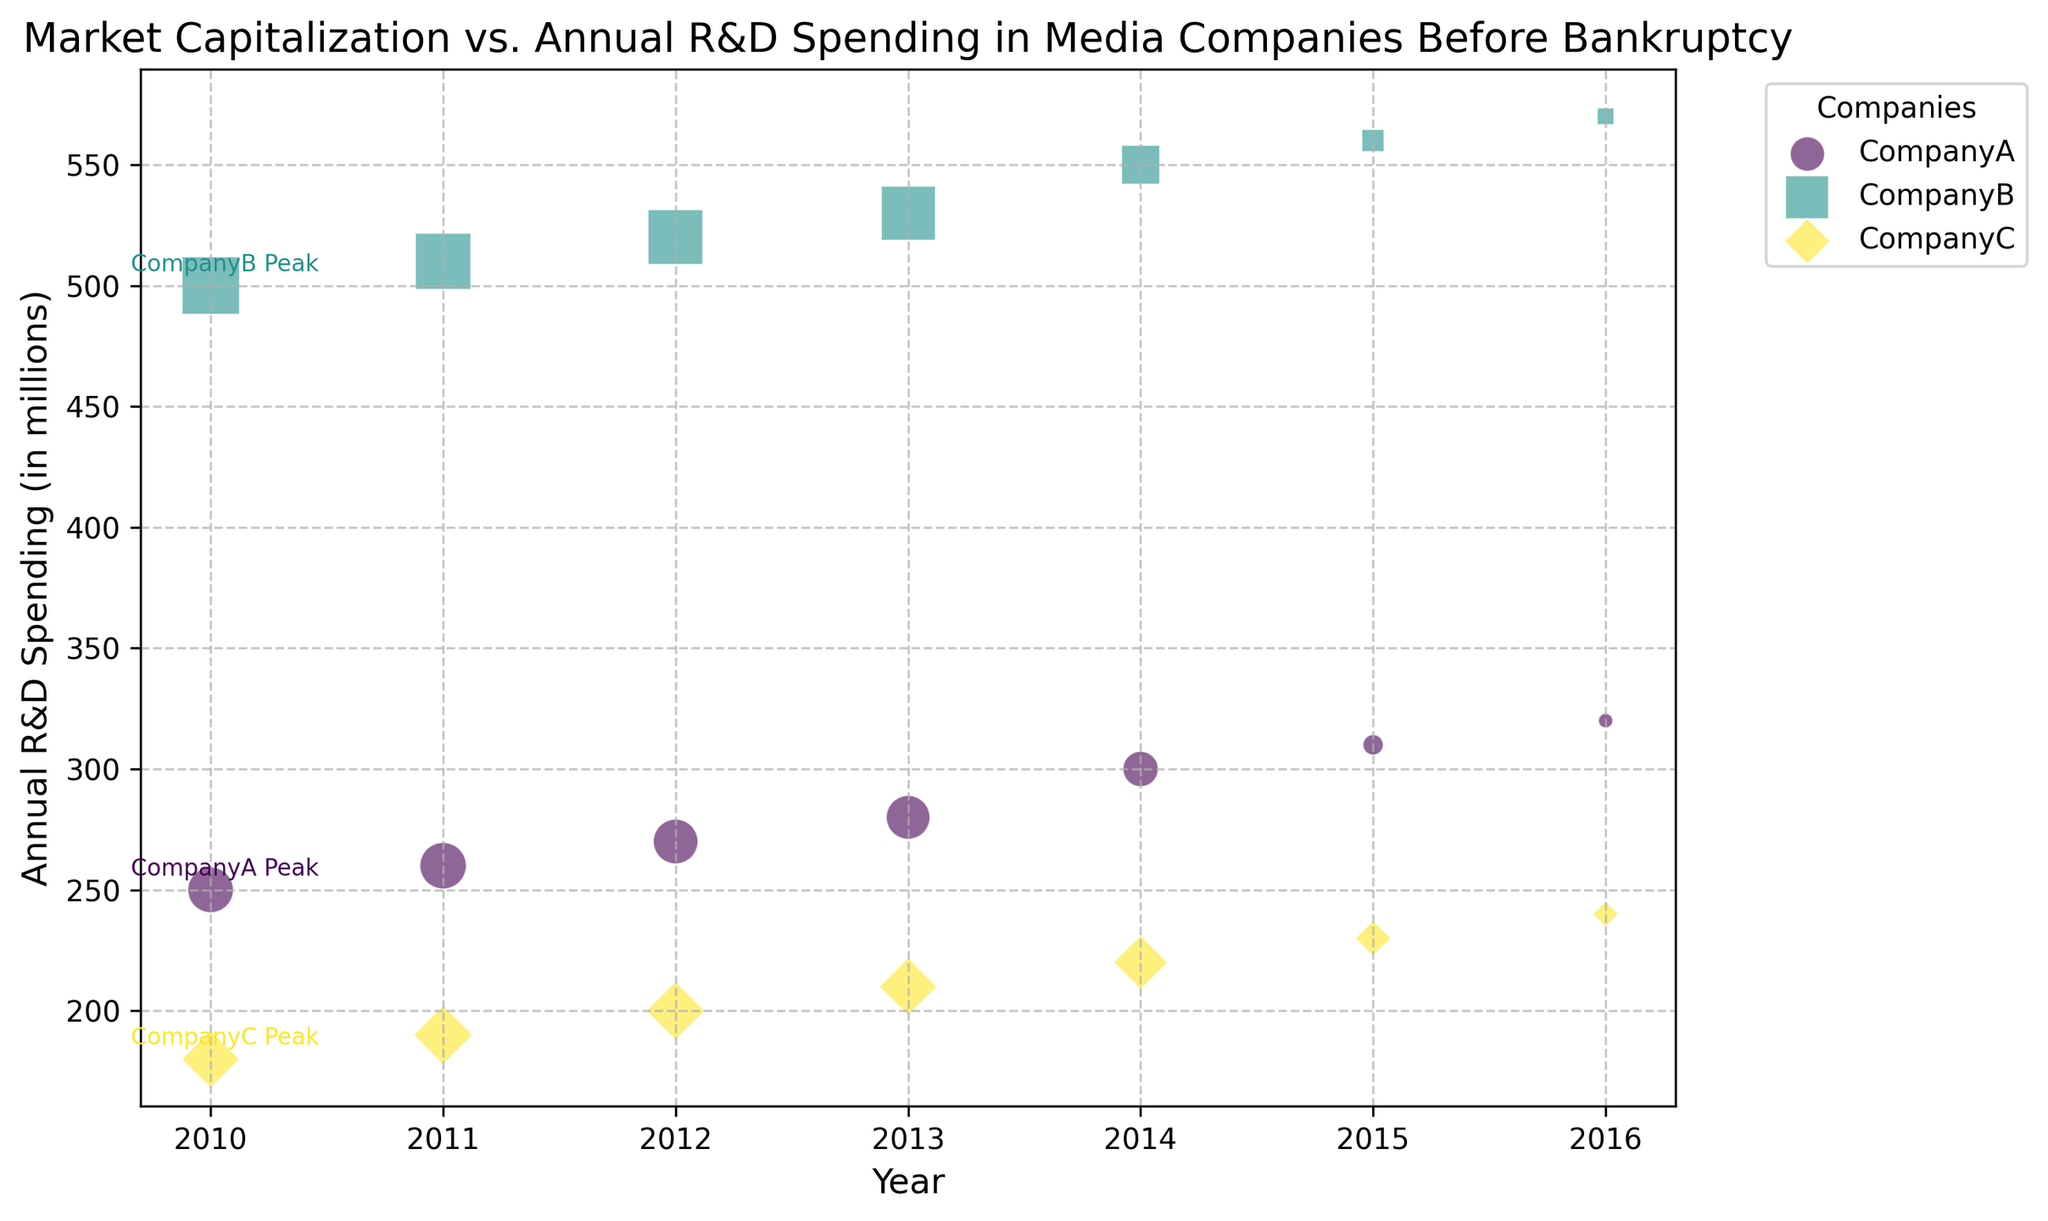what year did Company B have its peak R&D spending annotated, and what was the value? Locate the annotation for Company B peak year performance, which is identified visually near the data points for Company B. The annotation suggests the year and the corresponding R&D spending value.
Answer: 2010, 500 Which company had the highest R&D spending in their peak year? Check the annotated peak year performance for each company and compare the R&D spending values. The company with the highest value is the answer.
Answer: Company B During which years did Company A's Market Capitalization see the largest drop, based on the shift in marker size? Look for the biggest visible decrease in marker size for Company A, indicating a significant drop in market capitalization. This drop is most pronounced between the years 2014 and 2015.
Answer: Between 2014 and 2015 How does Company C's R&D spending trend over the years compare to its Market Capitalization trend? Identify the trend of annual R&D spending and compare it visually to the marker sizes representing market capitalization for Company C over the years. You will observe that R&D spending increases while market capitalization decreases.
Answer: Inverse trends What is the difference in R&D spending between Company B's peak year and its R&D spending in 2015? Identify Company B's peak year R&D spending (annotated on the plot) and R&D spending in 2015. Subtract the latter from the former to get the difference. The values are 500 and 560 respectively. The difference is 500 - 560 = -60.
Answer: -60 Between Company A and Company C, which one had a higher R&D spending in 2013? Locate the data points for Company A and Company C in the year 2013. Compare their Y-axis values (R&D spending).
Answer: Company A Does the annotation indicate Company A's peak year performance was the same as the peak year for R&D spending? Look at the annotated peak year performance for Company A and check if the R&D spending value matches the one in the year of peak performance. The peak performance is annotated at the year 2010, while the R&D peak is not annotated at the same year.
Answer: No By how much did Company's B market capitalization decrease from 2010 to 2015? Observe the marker sizes for Company B in the years 2010 and 2015. Note the values and calculate the difference (from 8000 to 1200). Subtract to find the decrease: 8000 - 1200 = 6800.
Answer: 6800 Which company had the smallest market capitalization throughout the period? Compare the smallest marker sizes across all companies. Company A has the smallest marker in the year 2016.
Answer: Company A 